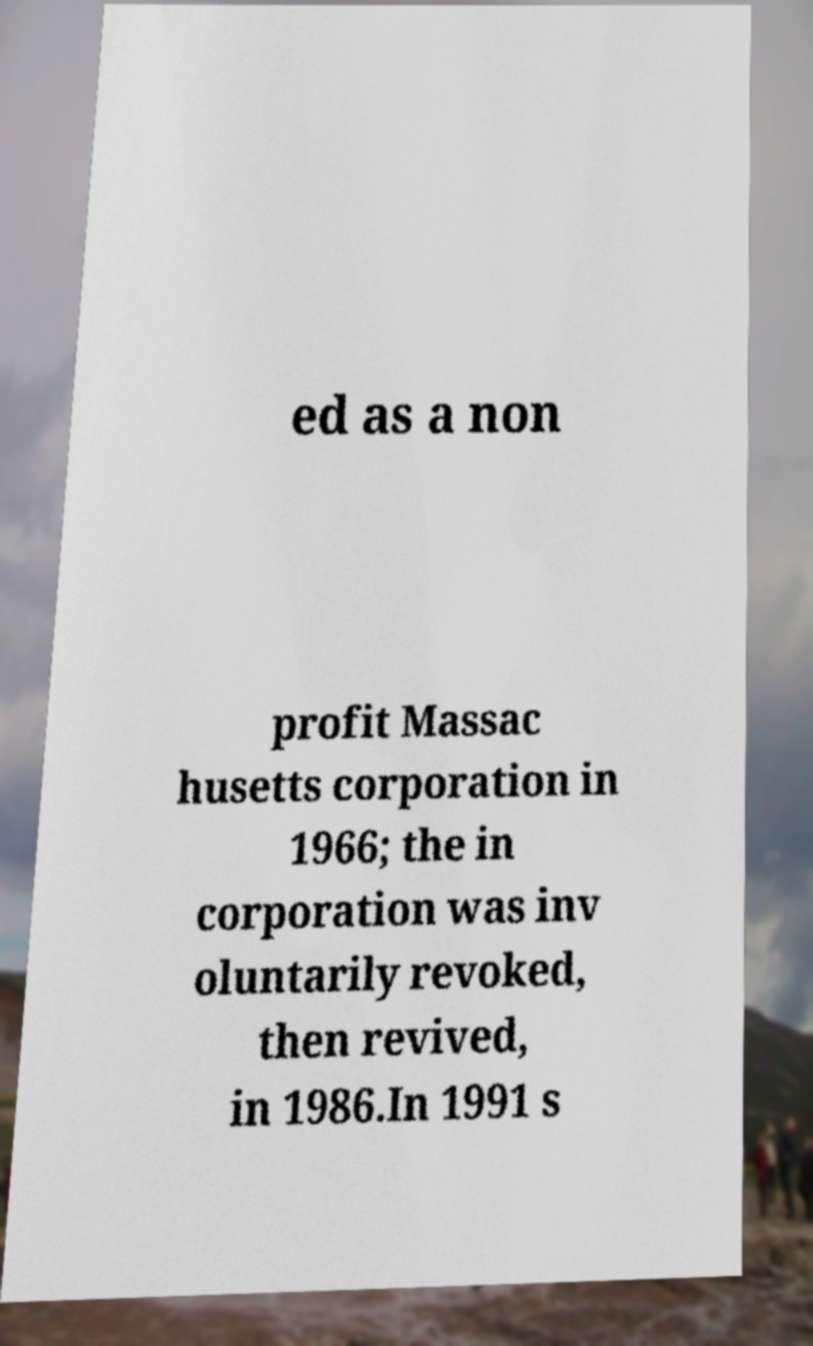For documentation purposes, I need the text within this image transcribed. Could you provide that? ed as a non profit Massac husetts corporation in 1966; the in corporation was inv oluntarily revoked, then revived, in 1986.In 1991 s 